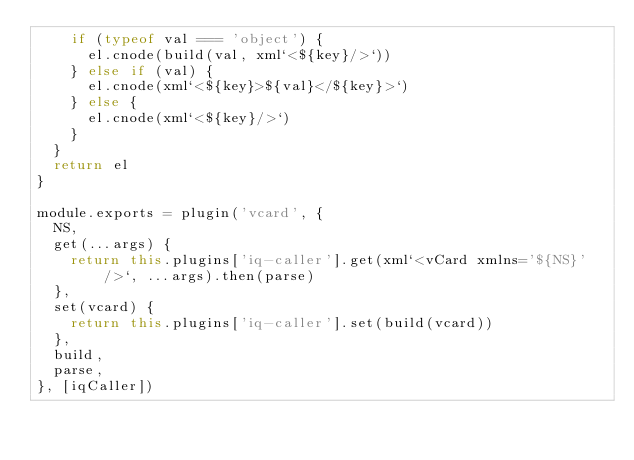Convert code to text. <code><loc_0><loc_0><loc_500><loc_500><_JavaScript_>    if (typeof val === 'object') {
      el.cnode(build(val, xml`<${key}/>`))
    } else if (val) {
      el.cnode(xml`<${key}>${val}</${key}>`)
    } else {
      el.cnode(xml`<${key}/>`)
    }
  }
  return el
}

module.exports = plugin('vcard', {
  NS,
  get(...args) {
    return this.plugins['iq-caller'].get(xml`<vCard xmlns='${NS}'/>`, ...args).then(parse)
  },
  set(vcard) {
    return this.plugins['iq-caller'].set(build(vcard))
  },
  build,
  parse,
}, [iqCaller])
</code> 